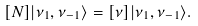Convert formula to latex. <formula><loc_0><loc_0><loc_500><loc_500>[ N ] | \nu _ { 1 } , \nu _ { - 1 } \rangle = [ \nu ] | \nu _ { 1 } , \nu _ { - 1 } \rangle .</formula> 